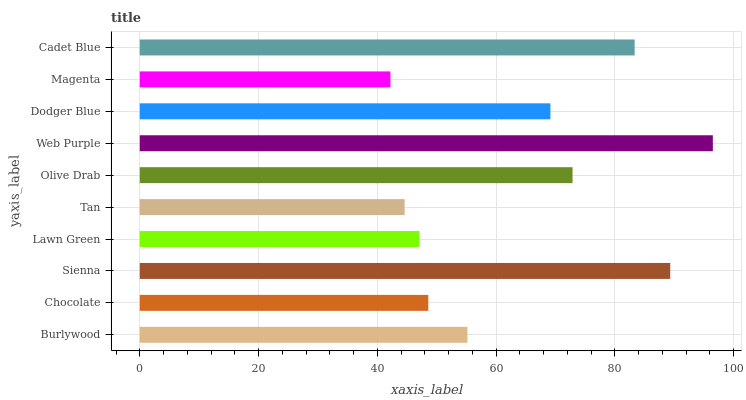Is Magenta the minimum?
Answer yes or no. Yes. Is Web Purple the maximum?
Answer yes or no. Yes. Is Chocolate the minimum?
Answer yes or no. No. Is Chocolate the maximum?
Answer yes or no. No. Is Burlywood greater than Chocolate?
Answer yes or no. Yes. Is Chocolate less than Burlywood?
Answer yes or no. Yes. Is Chocolate greater than Burlywood?
Answer yes or no. No. Is Burlywood less than Chocolate?
Answer yes or no. No. Is Dodger Blue the high median?
Answer yes or no. Yes. Is Burlywood the low median?
Answer yes or no. Yes. Is Sienna the high median?
Answer yes or no. No. Is Chocolate the low median?
Answer yes or no. No. 